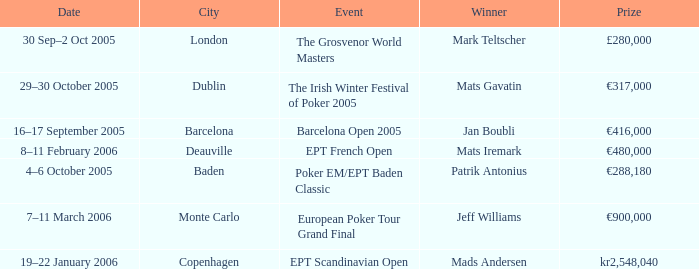What event did Mark Teltscher win? The Grosvenor World Masters. 